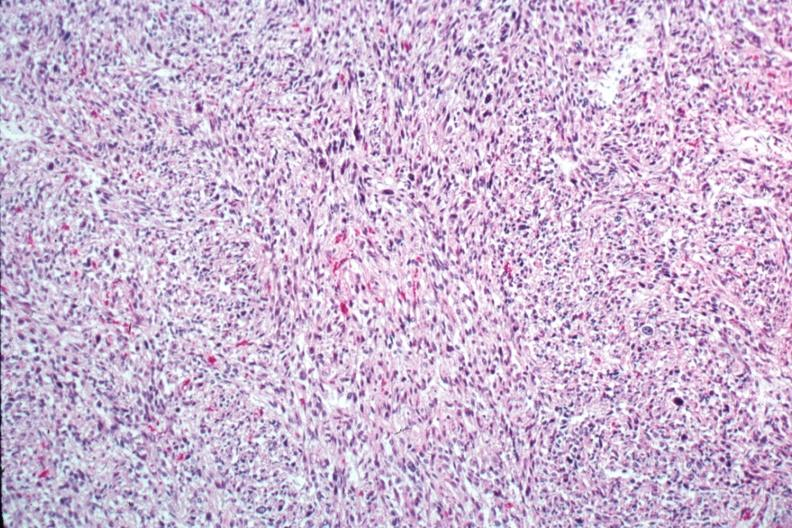does this image show excellent photo of pleomorphic spindle cell tumor with storiform pattern?
Answer the question using a single word or phrase. Yes 